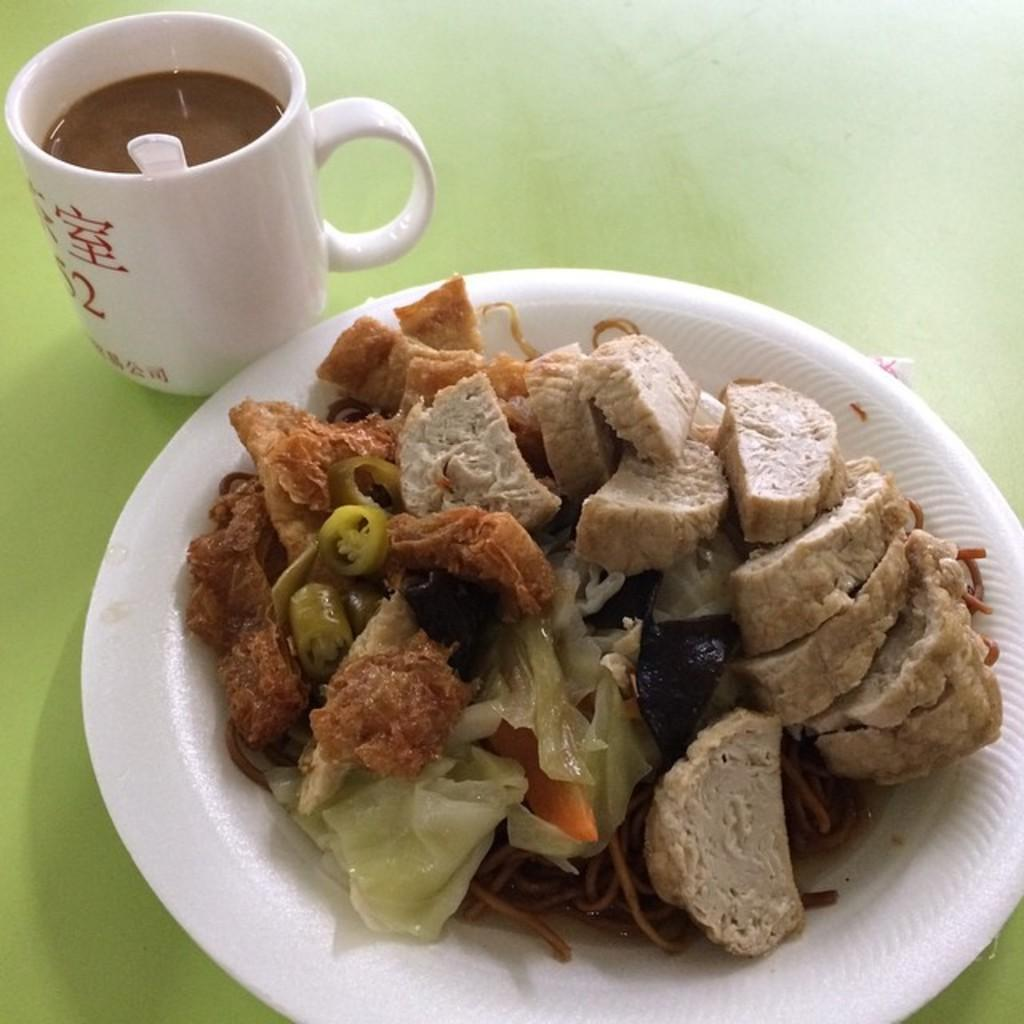What is on the plate that is visible in the image? There is food on a plate in the image. What beverage is in the cup that is visible in the image? There is a cup of coffee in the image. Where are the plate and cup located in the image? The plate and cup are placed on a table. What month is it in the image? The month cannot be determined from the image, as it only shows food on a plate and a cup of coffee on a table. What language is spoken by the food in the image? The food does not speak a language, as it is an inanimate object. 